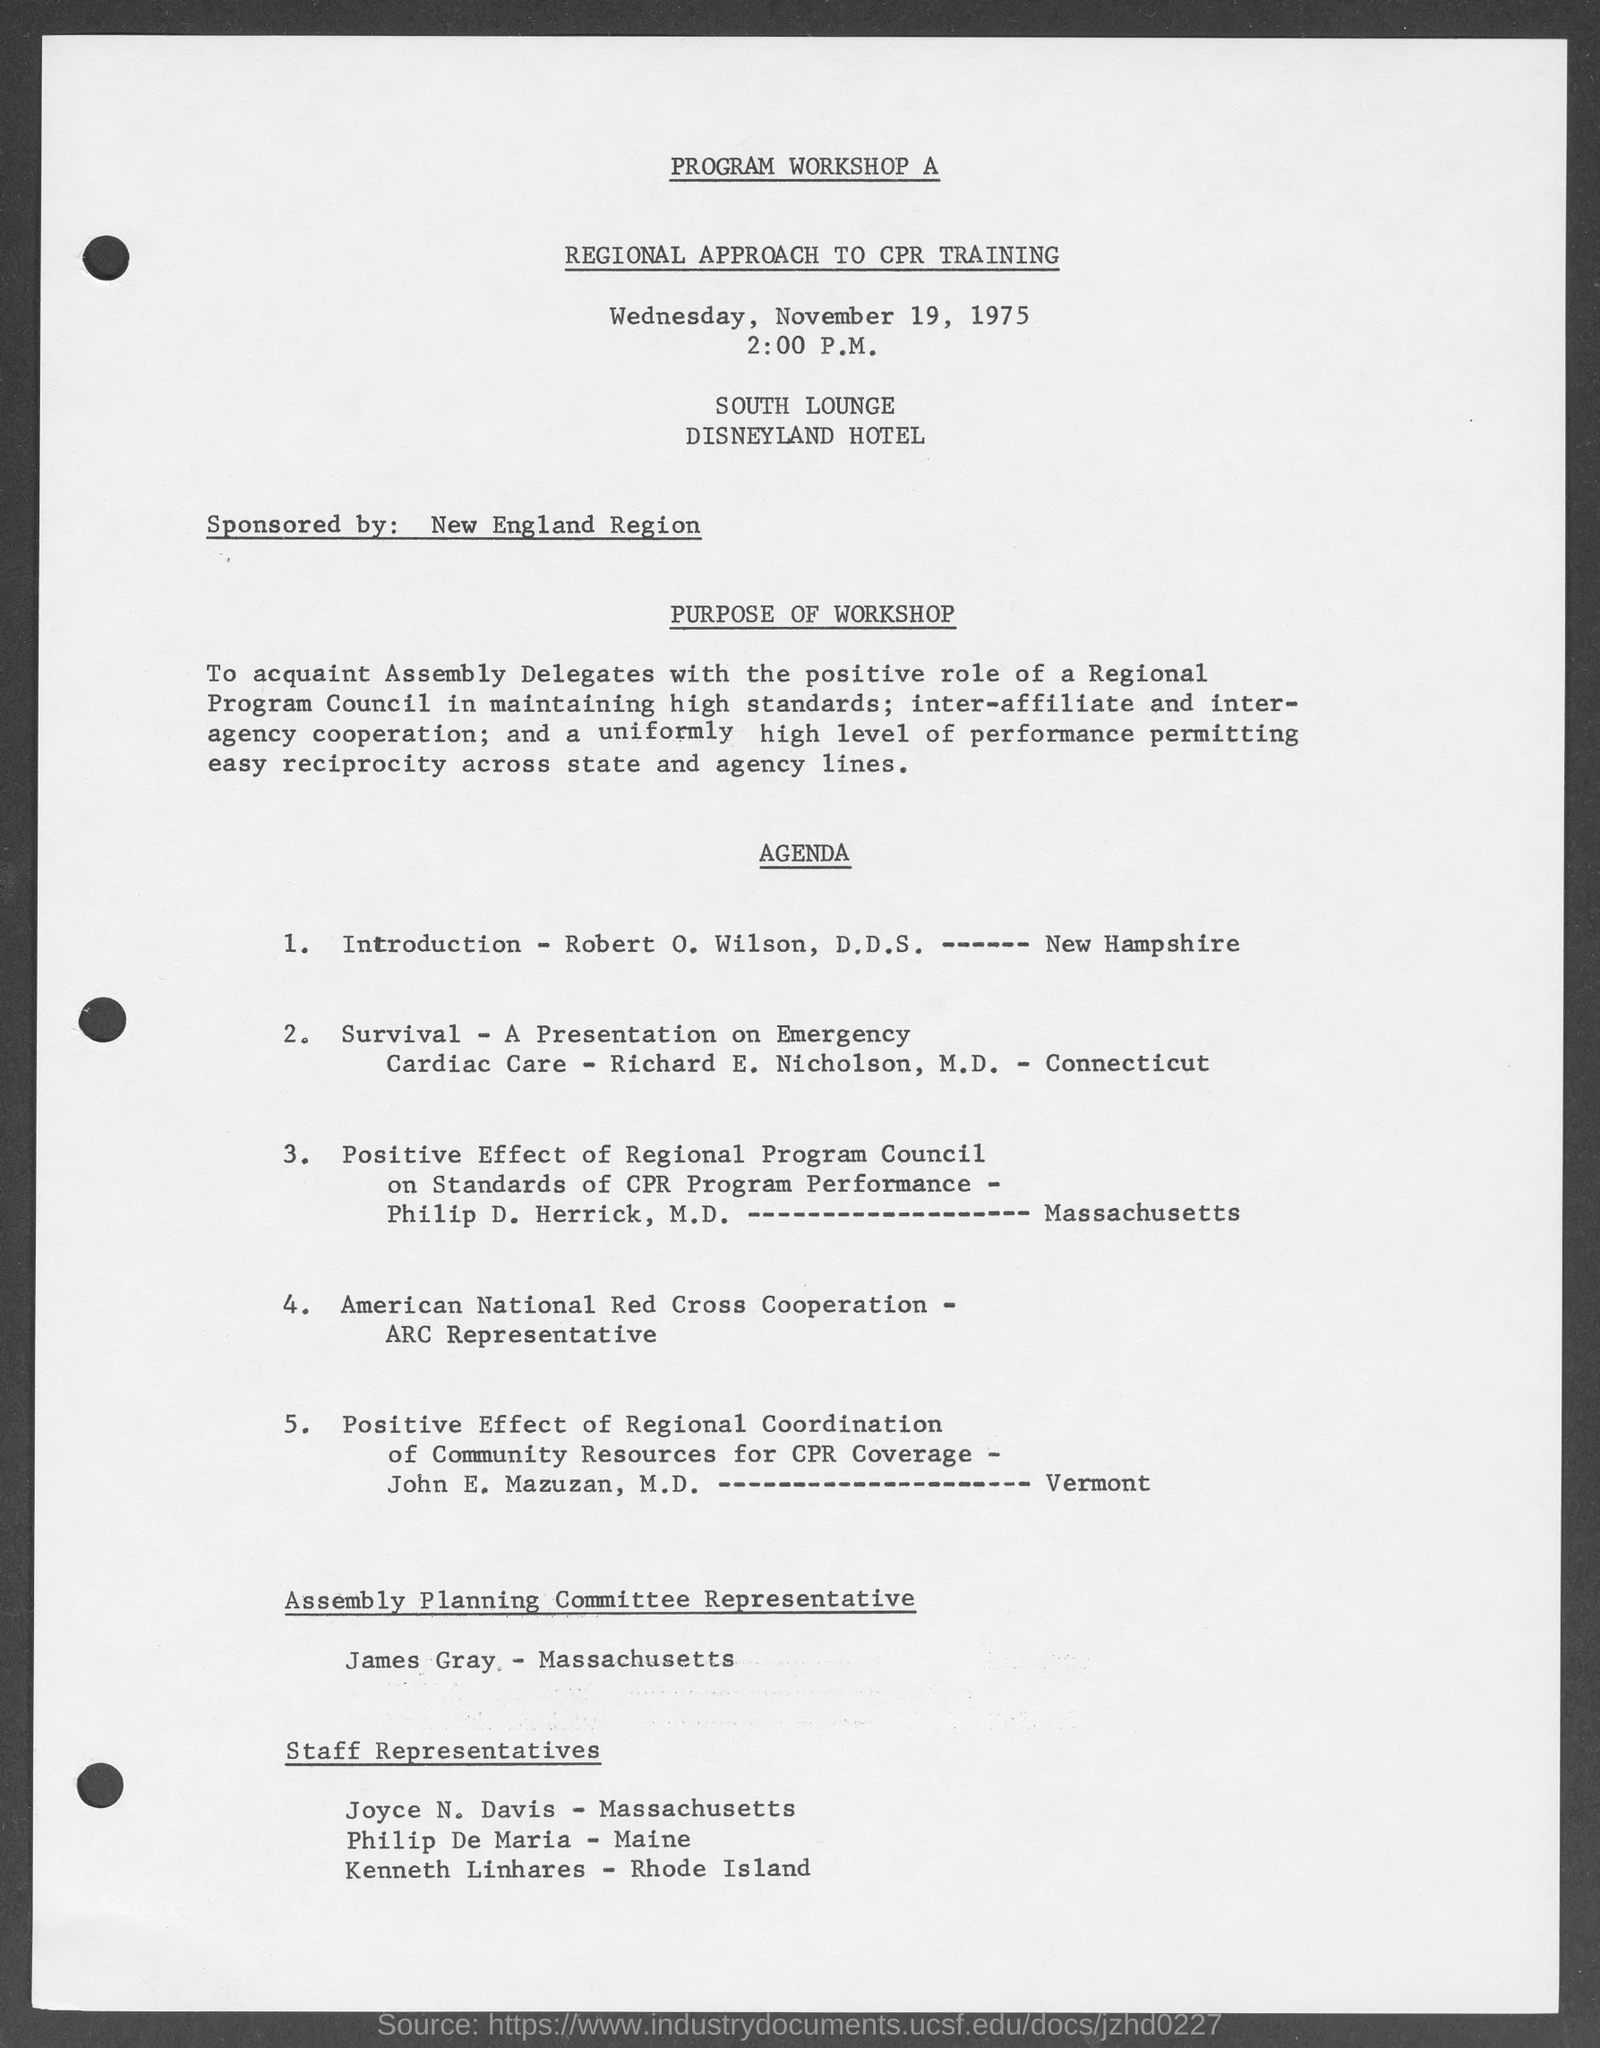Draw attention to some important aspects in this diagram. The agenda indicates that James Gray is the representative of the Assembly Planning Committee. The workshop will be organized at the South Lounge in the Disneyland Hotel. 